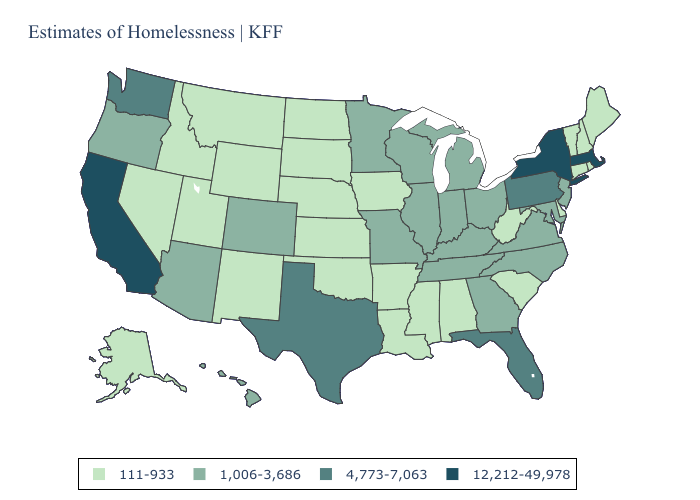What is the value of Iowa?
Be succinct. 111-933. Name the states that have a value in the range 12,212-49,978?
Answer briefly. California, Massachusetts, New York. Name the states that have a value in the range 111-933?
Give a very brief answer. Alabama, Alaska, Arkansas, Connecticut, Delaware, Idaho, Iowa, Kansas, Louisiana, Maine, Mississippi, Montana, Nebraska, Nevada, New Hampshire, New Mexico, North Dakota, Oklahoma, Rhode Island, South Carolina, South Dakota, Utah, Vermont, West Virginia, Wyoming. Does Arizona have the highest value in the USA?
Concise answer only. No. Name the states that have a value in the range 12,212-49,978?
Concise answer only. California, Massachusetts, New York. What is the lowest value in the MidWest?
Concise answer only. 111-933. Name the states that have a value in the range 1,006-3,686?
Keep it brief. Arizona, Colorado, Georgia, Hawaii, Illinois, Indiana, Kentucky, Maryland, Michigan, Minnesota, Missouri, New Jersey, North Carolina, Ohio, Oregon, Tennessee, Virginia, Wisconsin. Does Massachusetts have the highest value in the USA?
Quick response, please. Yes. Does Oklahoma have the same value as Ohio?
Short answer required. No. What is the lowest value in states that border Mississippi?
Short answer required. 111-933. What is the value of California?
Be succinct. 12,212-49,978. What is the value of Alabama?
Quick response, please. 111-933. What is the lowest value in the USA?
Give a very brief answer. 111-933. What is the value of New York?
Concise answer only. 12,212-49,978. Does the first symbol in the legend represent the smallest category?
Answer briefly. Yes. 